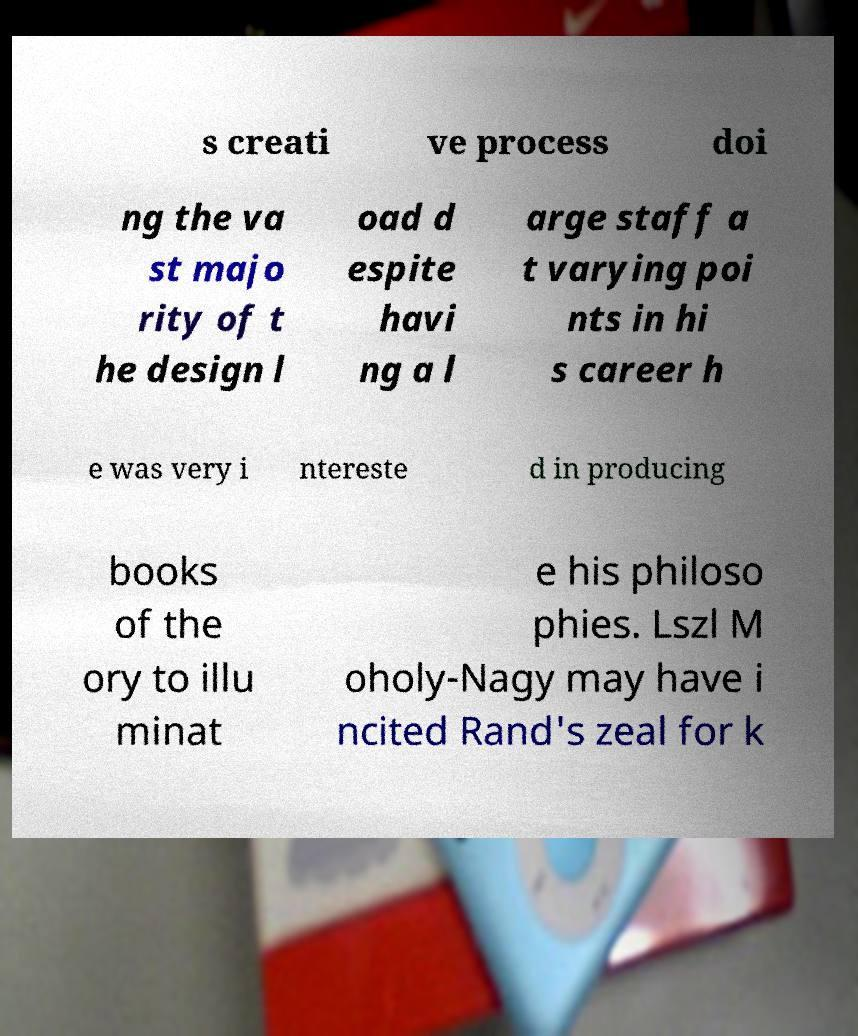There's text embedded in this image that I need extracted. Can you transcribe it verbatim? s creati ve process doi ng the va st majo rity of t he design l oad d espite havi ng a l arge staff a t varying poi nts in hi s career h e was very i ntereste d in producing books of the ory to illu minat e his philoso phies. Lszl M oholy-Nagy may have i ncited Rand's zeal for k 